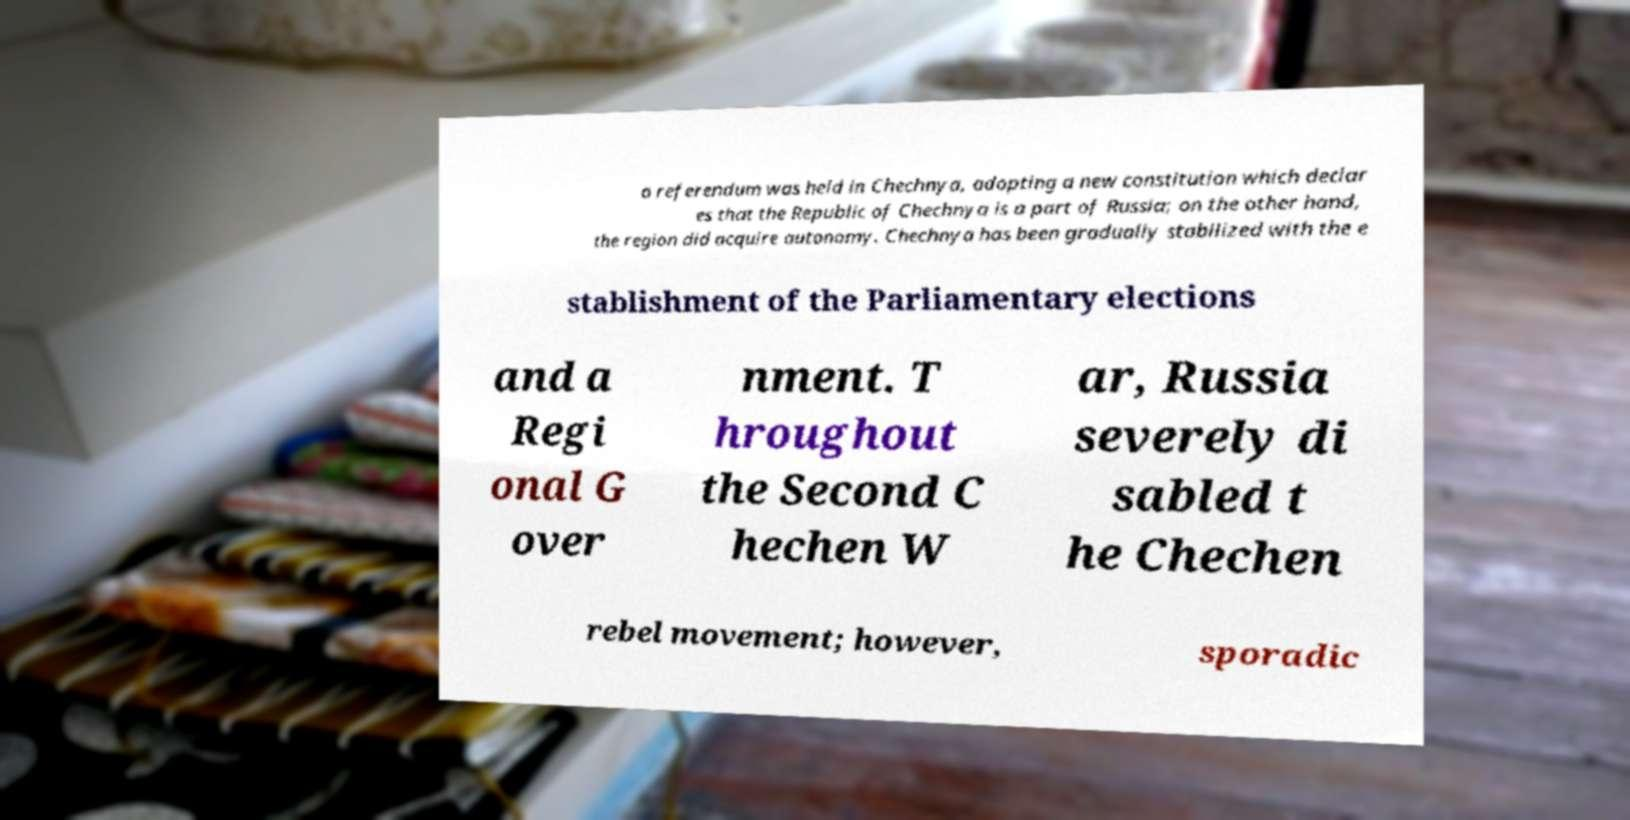Please identify and transcribe the text found in this image. a referendum was held in Chechnya, adopting a new constitution which declar es that the Republic of Chechnya is a part of Russia; on the other hand, the region did acquire autonomy. Chechnya has been gradually stabilized with the e stablishment of the Parliamentary elections and a Regi onal G over nment. T hroughout the Second C hechen W ar, Russia severely di sabled t he Chechen rebel movement; however, sporadic 